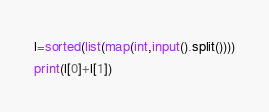<code> <loc_0><loc_0><loc_500><loc_500><_Python_>l=sorted(list(map(int,input().split())))
print(l[0]+l[1])</code> 